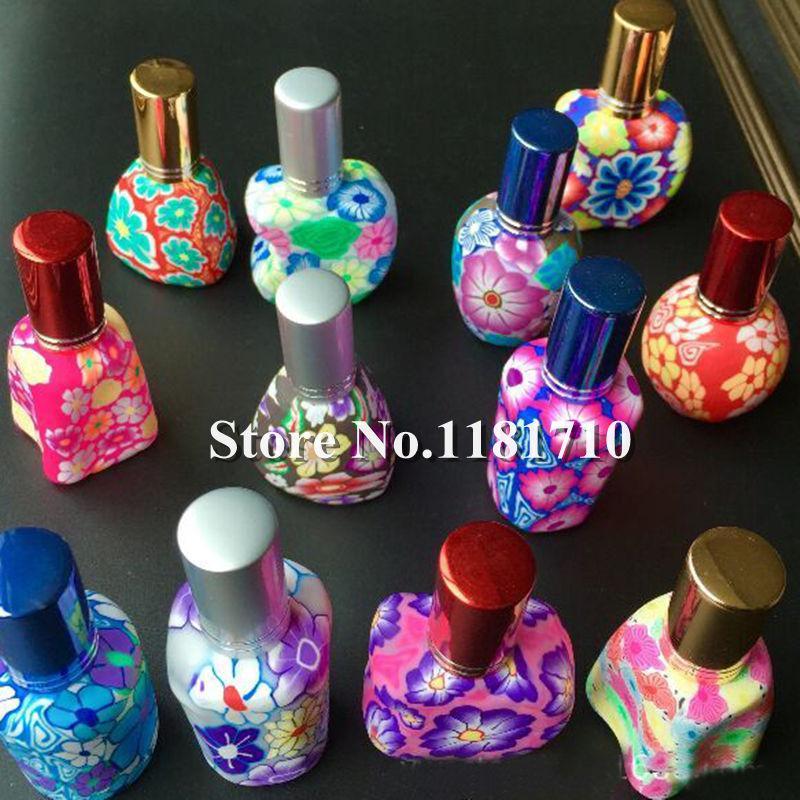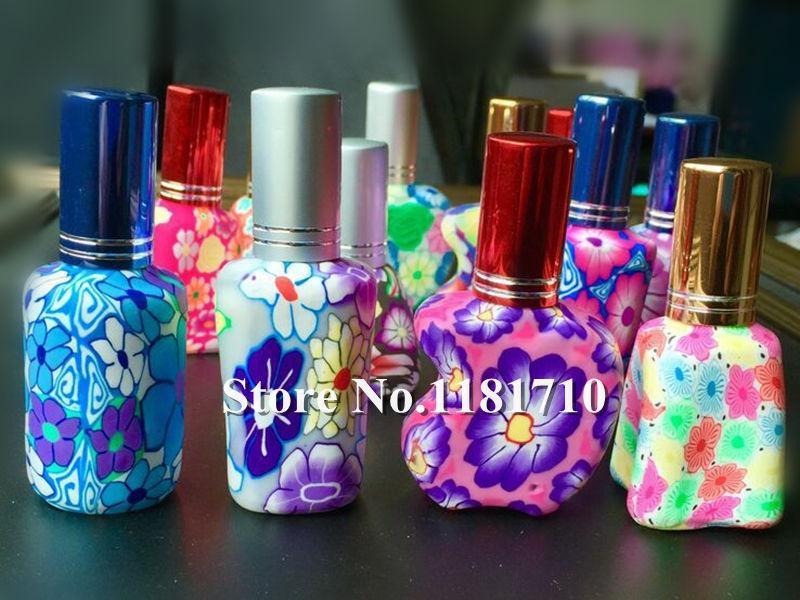The first image is the image on the left, the second image is the image on the right. Examine the images to the left and right. Is the description "At least 4 bottles are lined up in a straight row." accurate? Answer yes or no. Yes. The first image is the image on the left, the second image is the image on the right. Examine the images to the left and right. Is the description "All bottles have wooden caps and at least one bottle has a braided strap attached." accurate? Answer yes or no. No. 